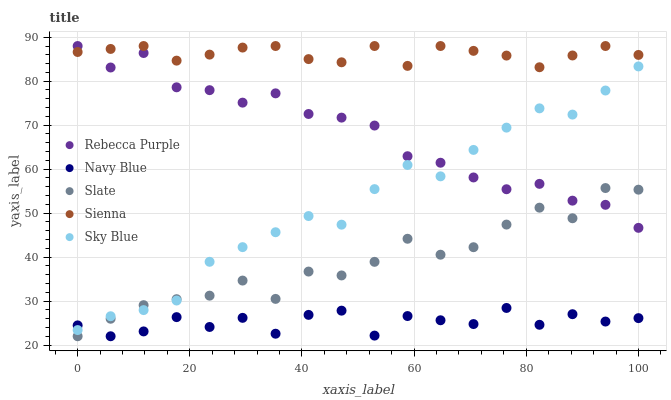Does Navy Blue have the minimum area under the curve?
Answer yes or no. Yes. Does Sienna have the maximum area under the curve?
Answer yes or no. Yes. Does Slate have the minimum area under the curve?
Answer yes or no. No. Does Slate have the maximum area under the curve?
Answer yes or no. No. Is Sienna the smoothest?
Answer yes or no. Yes. Is Navy Blue the roughest?
Answer yes or no. Yes. Is Slate the smoothest?
Answer yes or no. No. Is Slate the roughest?
Answer yes or no. No. Does Navy Blue have the lowest value?
Answer yes or no. Yes. Does Rebecca Purple have the lowest value?
Answer yes or no. No. Does Rebecca Purple have the highest value?
Answer yes or no. Yes. Does Slate have the highest value?
Answer yes or no. No. Is Navy Blue less than Sienna?
Answer yes or no. Yes. Is Sienna greater than Navy Blue?
Answer yes or no. Yes. Does Navy Blue intersect Sky Blue?
Answer yes or no. Yes. Is Navy Blue less than Sky Blue?
Answer yes or no. No. Is Navy Blue greater than Sky Blue?
Answer yes or no. No. Does Navy Blue intersect Sienna?
Answer yes or no. No. 